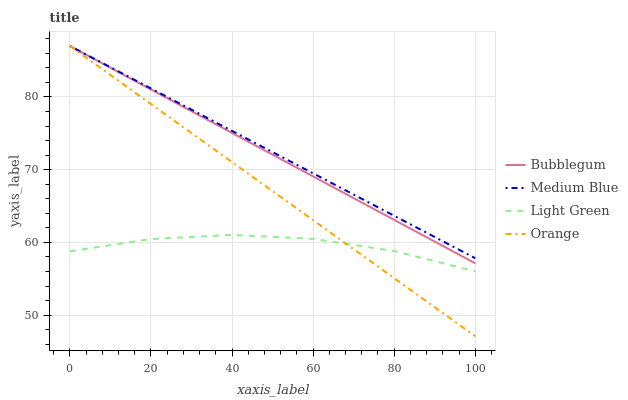Does Light Green have the minimum area under the curve?
Answer yes or no. Yes. Does Medium Blue have the maximum area under the curve?
Answer yes or no. Yes. Does Medium Blue have the minimum area under the curve?
Answer yes or no. No. Does Light Green have the maximum area under the curve?
Answer yes or no. No. Is Medium Blue the smoothest?
Answer yes or no. Yes. Is Light Green the roughest?
Answer yes or no. Yes. Is Light Green the smoothest?
Answer yes or no. No. Is Medium Blue the roughest?
Answer yes or no. No. Does Light Green have the lowest value?
Answer yes or no. No. Does Bubblegum have the highest value?
Answer yes or no. Yes. Does Light Green have the highest value?
Answer yes or no. No. Is Light Green less than Bubblegum?
Answer yes or no. Yes. Is Bubblegum greater than Light Green?
Answer yes or no. Yes. Does Light Green intersect Bubblegum?
Answer yes or no. No. 